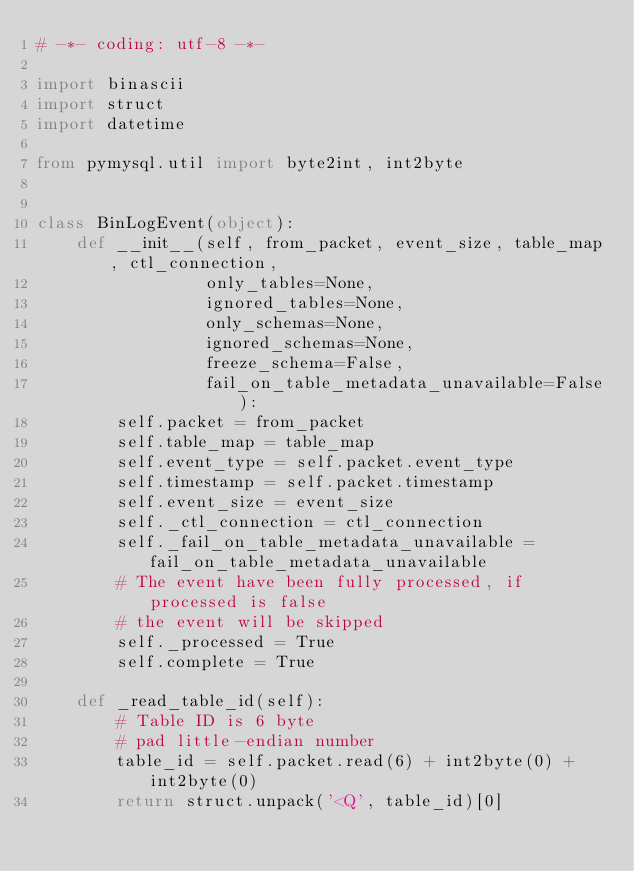Convert code to text. <code><loc_0><loc_0><loc_500><loc_500><_Python_># -*- coding: utf-8 -*-

import binascii
import struct
import datetime

from pymysql.util import byte2int, int2byte


class BinLogEvent(object):
    def __init__(self, from_packet, event_size, table_map, ctl_connection,
                 only_tables=None,
                 ignored_tables=None,
                 only_schemas=None,
                 ignored_schemas=None,
                 freeze_schema=False,
                 fail_on_table_metadata_unavailable=False):
        self.packet = from_packet
        self.table_map = table_map
        self.event_type = self.packet.event_type
        self.timestamp = self.packet.timestamp
        self.event_size = event_size
        self._ctl_connection = ctl_connection
        self._fail_on_table_metadata_unavailable = fail_on_table_metadata_unavailable
        # The event have been fully processed, if processed is false
        # the event will be skipped
        self._processed = True
        self.complete = True

    def _read_table_id(self):
        # Table ID is 6 byte
        # pad little-endian number
        table_id = self.packet.read(6) + int2byte(0) + int2byte(0)
        return struct.unpack('<Q', table_id)[0]
</code> 